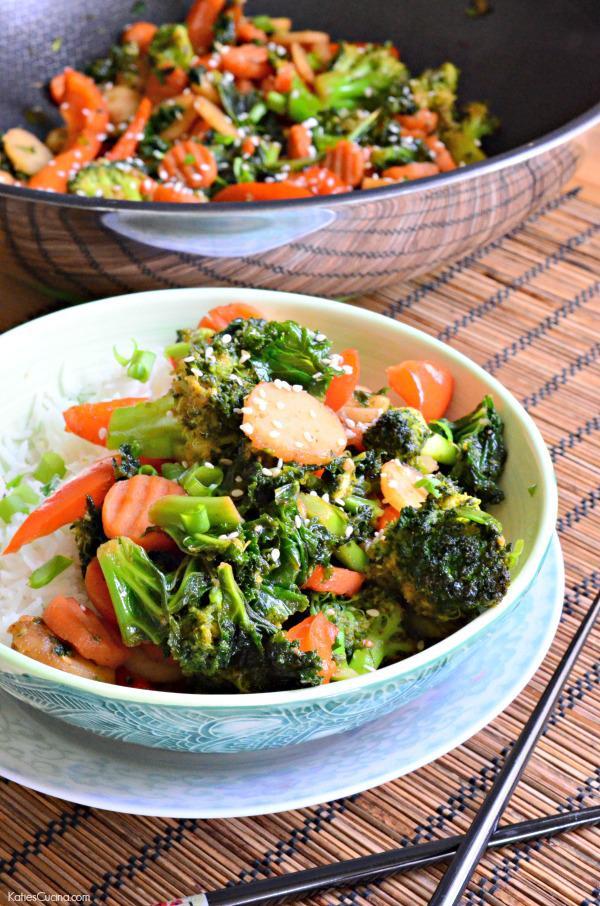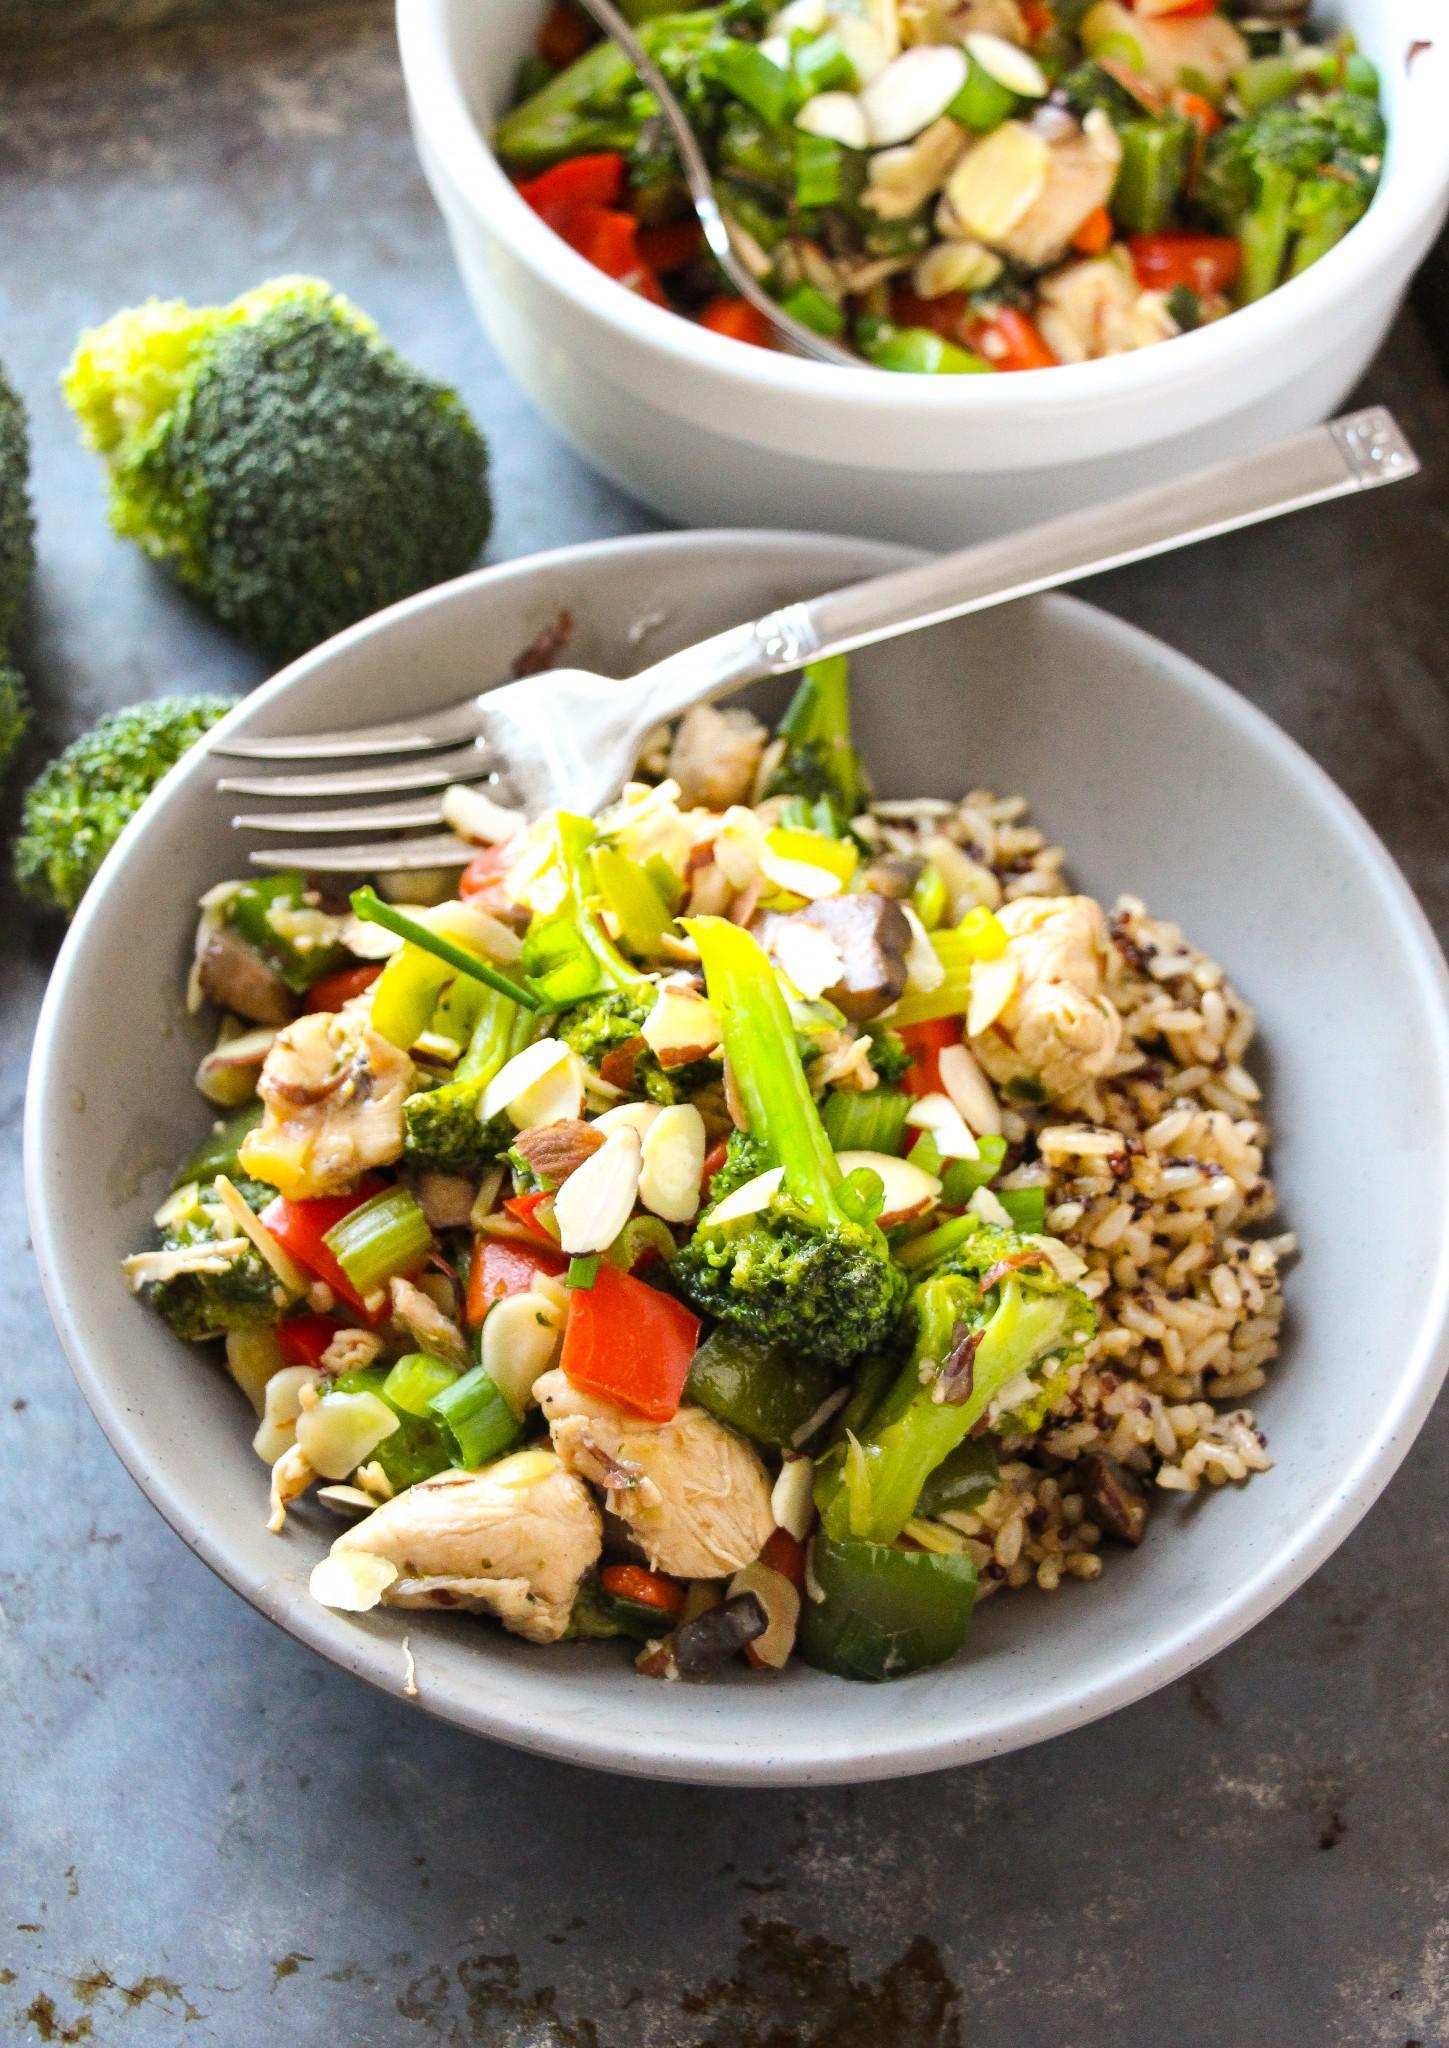The first image is the image on the left, the second image is the image on the right. For the images shown, is this caption "A fork is inside the bowl of one of the stir-frys in one image." true? Answer yes or no. Yes. The first image is the image on the left, the second image is the image on the right. Assess this claim about the two images: "The left and right image contains two white bowl of broccoli and chickens.". Correct or not? Answer yes or no. No. 